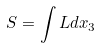Convert formula to latex. <formula><loc_0><loc_0><loc_500><loc_500>S = \int L d x _ { 3 }</formula> 